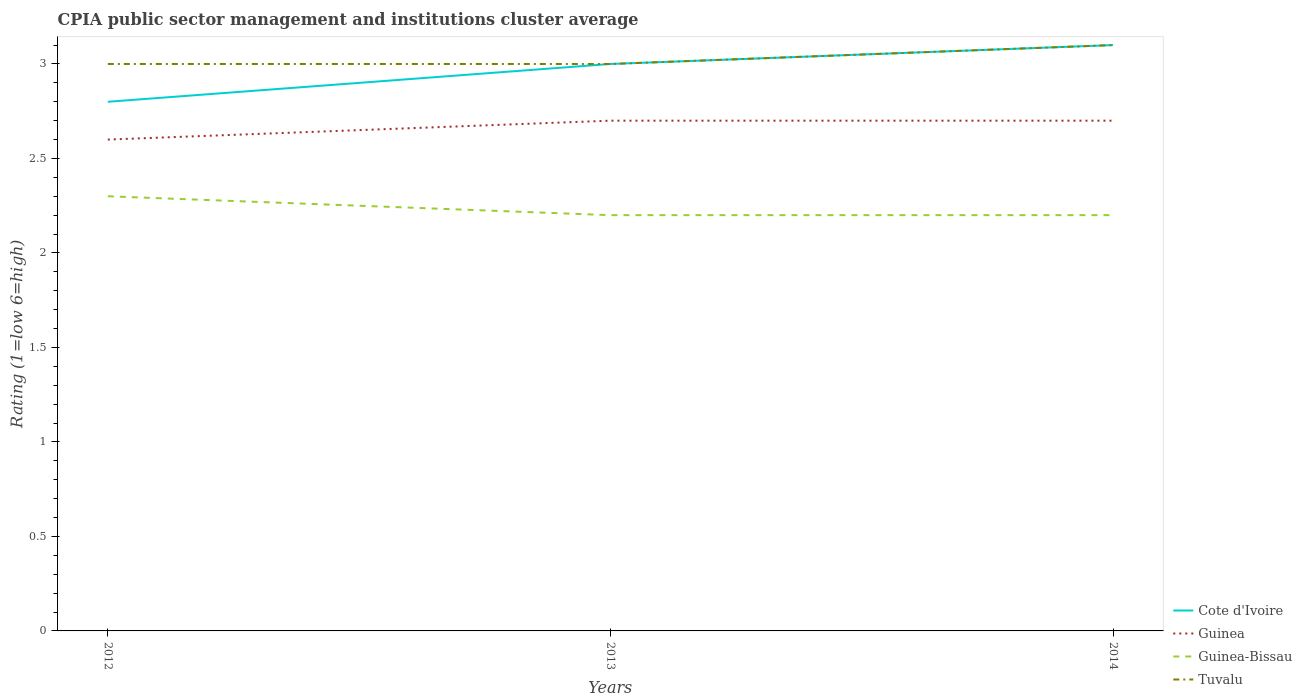How many different coloured lines are there?
Ensure brevity in your answer.  4. Across all years, what is the maximum CPIA rating in Guinea-Bissau?
Your response must be concise. 2.2. What is the total CPIA rating in Guinea in the graph?
Ensure brevity in your answer.  -0.1. What is the difference between the highest and the second highest CPIA rating in Cote d'Ivoire?
Your response must be concise. 0.3. How many lines are there?
Give a very brief answer. 4. How many years are there in the graph?
Your answer should be compact. 3. What is the difference between two consecutive major ticks on the Y-axis?
Your answer should be very brief. 0.5. Does the graph contain grids?
Your answer should be very brief. No. Where does the legend appear in the graph?
Your answer should be very brief. Bottom right. How many legend labels are there?
Provide a succinct answer. 4. How are the legend labels stacked?
Your answer should be compact. Vertical. What is the title of the graph?
Ensure brevity in your answer.  CPIA public sector management and institutions cluster average. Does "Ukraine" appear as one of the legend labels in the graph?
Your response must be concise. No. What is the Rating (1=low 6=high) in Cote d'Ivoire in 2012?
Offer a very short reply. 2.8. What is the Rating (1=low 6=high) in Cote d'Ivoire in 2013?
Provide a short and direct response. 3. What is the Rating (1=low 6=high) in Tuvalu in 2013?
Give a very brief answer. 3. What is the Rating (1=low 6=high) in Guinea-Bissau in 2014?
Your answer should be very brief. 2.2. Across all years, what is the maximum Rating (1=low 6=high) in Guinea?
Make the answer very short. 2.7. Across all years, what is the maximum Rating (1=low 6=high) in Guinea-Bissau?
Your answer should be very brief. 2.3. Across all years, what is the minimum Rating (1=low 6=high) of Tuvalu?
Ensure brevity in your answer.  3. What is the total Rating (1=low 6=high) of Cote d'Ivoire in the graph?
Your answer should be compact. 8.9. What is the total Rating (1=low 6=high) of Guinea in the graph?
Offer a terse response. 8. What is the total Rating (1=low 6=high) in Guinea-Bissau in the graph?
Give a very brief answer. 6.7. What is the difference between the Rating (1=low 6=high) of Cote d'Ivoire in 2012 and that in 2013?
Make the answer very short. -0.2. What is the difference between the Rating (1=low 6=high) of Guinea-Bissau in 2012 and that in 2013?
Ensure brevity in your answer.  0.1. What is the difference between the Rating (1=low 6=high) in Tuvalu in 2012 and that in 2013?
Provide a succinct answer. 0. What is the difference between the Rating (1=low 6=high) in Cote d'Ivoire in 2012 and that in 2014?
Ensure brevity in your answer.  -0.3. What is the difference between the Rating (1=low 6=high) in Guinea in 2012 and that in 2014?
Make the answer very short. -0.1. What is the difference between the Rating (1=low 6=high) of Cote d'Ivoire in 2013 and that in 2014?
Make the answer very short. -0.1. What is the difference between the Rating (1=low 6=high) in Guinea in 2013 and that in 2014?
Your response must be concise. 0. What is the difference between the Rating (1=low 6=high) in Guinea-Bissau in 2013 and that in 2014?
Provide a short and direct response. 0. What is the difference between the Rating (1=low 6=high) of Guinea in 2012 and the Rating (1=low 6=high) of Tuvalu in 2013?
Ensure brevity in your answer.  -0.4. What is the difference between the Rating (1=low 6=high) in Cote d'Ivoire in 2012 and the Rating (1=low 6=high) in Guinea-Bissau in 2014?
Give a very brief answer. 0.6. What is the difference between the Rating (1=low 6=high) in Guinea in 2012 and the Rating (1=low 6=high) in Guinea-Bissau in 2014?
Your answer should be very brief. 0.4. What is the difference between the Rating (1=low 6=high) in Guinea in 2012 and the Rating (1=low 6=high) in Tuvalu in 2014?
Your answer should be compact. -0.5. What is the difference between the Rating (1=low 6=high) of Guinea-Bissau in 2012 and the Rating (1=low 6=high) of Tuvalu in 2014?
Your answer should be very brief. -0.8. What is the difference between the Rating (1=low 6=high) in Cote d'Ivoire in 2013 and the Rating (1=low 6=high) in Guinea-Bissau in 2014?
Your answer should be compact. 0.8. What is the difference between the Rating (1=low 6=high) in Guinea in 2013 and the Rating (1=low 6=high) in Guinea-Bissau in 2014?
Offer a very short reply. 0.5. What is the difference between the Rating (1=low 6=high) in Guinea in 2013 and the Rating (1=low 6=high) in Tuvalu in 2014?
Offer a terse response. -0.4. What is the average Rating (1=low 6=high) in Cote d'Ivoire per year?
Provide a short and direct response. 2.97. What is the average Rating (1=low 6=high) of Guinea per year?
Your response must be concise. 2.67. What is the average Rating (1=low 6=high) of Guinea-Bissau per year?
Make the answer very short. 2.23. What is the average Rating (1=low 6=high) of Tuvalu per year?
Offer a very short reply. 3.03. In the year 2012, what is the difference between the Rating (1=low 6=high) in Cote d'Ivoire and Rating (1=low 6=high) in Guinea?
Provide a succinct answer. 0.2. In the year 2012, what is the difference between the Rating (1=low 6=high) in Cote d'Ivoire and Rating (1=low 6=high) in Tuvalu?
Provide a succinct answer. -0.2. In the year 2012, what is the difference between the Rating (1=low 6=high) in Guinea and Rating (1=low 6=high) in Guinea-Bissau?
Ensure brevity in your answer.  0.3. In the year 2013, what is the difference between the Rating (1=low 6=high) of Cote d'Ivoire and Rating (1=low 6=high) of Tuvalu?
Provide a short and direct response. 0. In the year 2013, what is the difference between the Rating (1=low 6=high) of Guinea and Rating (1=low 6=high) of Guinea-Bissau?
Give a very brief answer. 0.5. In the year 2013, what is the difference between the Rating (1=low 6=high) in Guinea and Rating (1=low 6=high) in Tuvalu?
Ensure brevity in your answer.  -0.3. In the year 2013, what is the difference between the Rating (1=low 6=high) of Guinea-Bissau and Rating (1=low 6=high) of Tuvalu?
Offer a terse response. -0.8. In the year 2014, what is the difference between the Rating (1=low 6=high) in Cote d'Ivoire and Rating (1=low 6=high) in Guinea?
Provide a succinct answer. 0.4. In the year 2014, what is the difference between the Rating (1=low 6=high) of Guinea-Bissau and Rating (1=low 6=high) of Tuvalu?
Provide a short and direct response. -0.9. What is the ratio of the Rating (1=low 6=high) of Guinea in 2012 to that in 2013?
Your answer should be very brief. 0.96. What is the ratio of the Rating (1=low 6=high) of Guinea-Bissau in 2012 to that in 2013?
Keep it short and to the point. 1.05. What is the ratio of the Rating (1=low 6=high) of Cote d'Ivoire in 2012 to that in 2014?
Your answer should be compact. 0.9. What is the ratio of the Rating (1=low 6=high) in Guinea in 2012 to that in 2014?
Make the answer very short. 0.96. What is the ratio of the Rating (1=low 6=high) in Guinea-Bissau in 2012 to that in 2014?
Ensure brevity in your answer.  1.05. What is the ratio of the Rating (1=low 6=high) in Tuvalu in 2012 to that in 2014?
Give a very brief answer. 0.97. What is the ratio of the Rating (1=low 6=high) of Cote d'Ivoire in 2013 to that in 2014?
Your response must be concise. 0.97. What is the ratio of the Rating (1=low 6=high) of Guinea in 2013 to that in 2014?
Your answer should be very brief. 1. What is the ratio of the Rating (1=low 6=high) of Tuvalu in 2013 to that in 2014?
Provide a short and direct response. 0.97. What is the difference between the highest and the second highest Rating (1=low 6=high) in Guinea?
Give a very brief answer. 0. What is the difference between the highest and the second highest Rating (1=low 6=high) in Tuvalu?
Offer a terse response. 0.1. What is the difference between the highest and the lowest Rating (1=low 6=high) in Cote d'Ivoire?
Ensure brevity in your answer.  0.3. What is the difference between the highest and the lowest Rating (1=low 6=high) of Guinea-Bissau?
Your response must be concise. 0.1. What is the difference between the highest and the lowest Rating (1=low 6=high) of Tuvalu?
Offer a terse response. 0.1. 